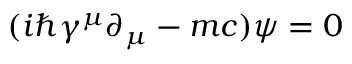Convert formula to latex. <formula><loc_0><loc_0><loc_500><loc_500>\ ( i \hbar { \gamma } ^ { \mu } \partial _ { \mu } - m c ) \psi = 0</formula> 